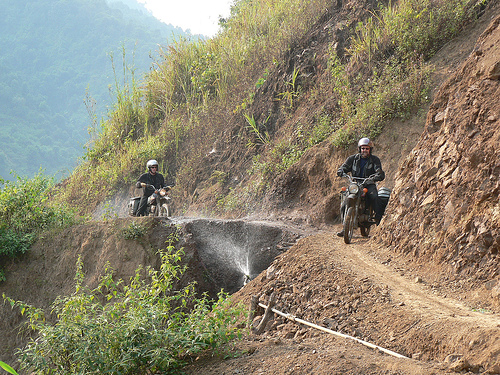How do the motorbikes and riders seem to be handling the environment? Both riders appear to be managing the difficult terrain with cautious expertise. The lead rider is slightly leaning forward, perhaps to maintain balance and control on the uneven path, while the following rider seems to maintain a steady pace. The posture and handling of the motorbikes suggest that they are experienced in navigating such off-road conditions. 